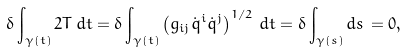<formula> <loc_0><loc_0><loc_500><loc_500>\delta \int _ { \gamma ( t ) } 2 T \, d t = \delta \int _ { \gamma ( t ) } \left ( g _ { i j } \dot { q } ^ { i } \dot { q } ^ { j } \right ) ^ { 1 / 2 } \, d t = \delta \int _ { \gamma ( s ) } d s \, = 0 ,</formula> 